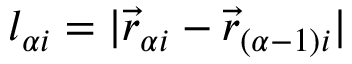Convert formula to latex. <formula><loc_0><loc_0><loc_500><loc_500>l _ { \alpha i } = | \vec { r } _ { \alpha i } - \vec { r } _ { ( \alpha - 1 ) i } |</formula> 